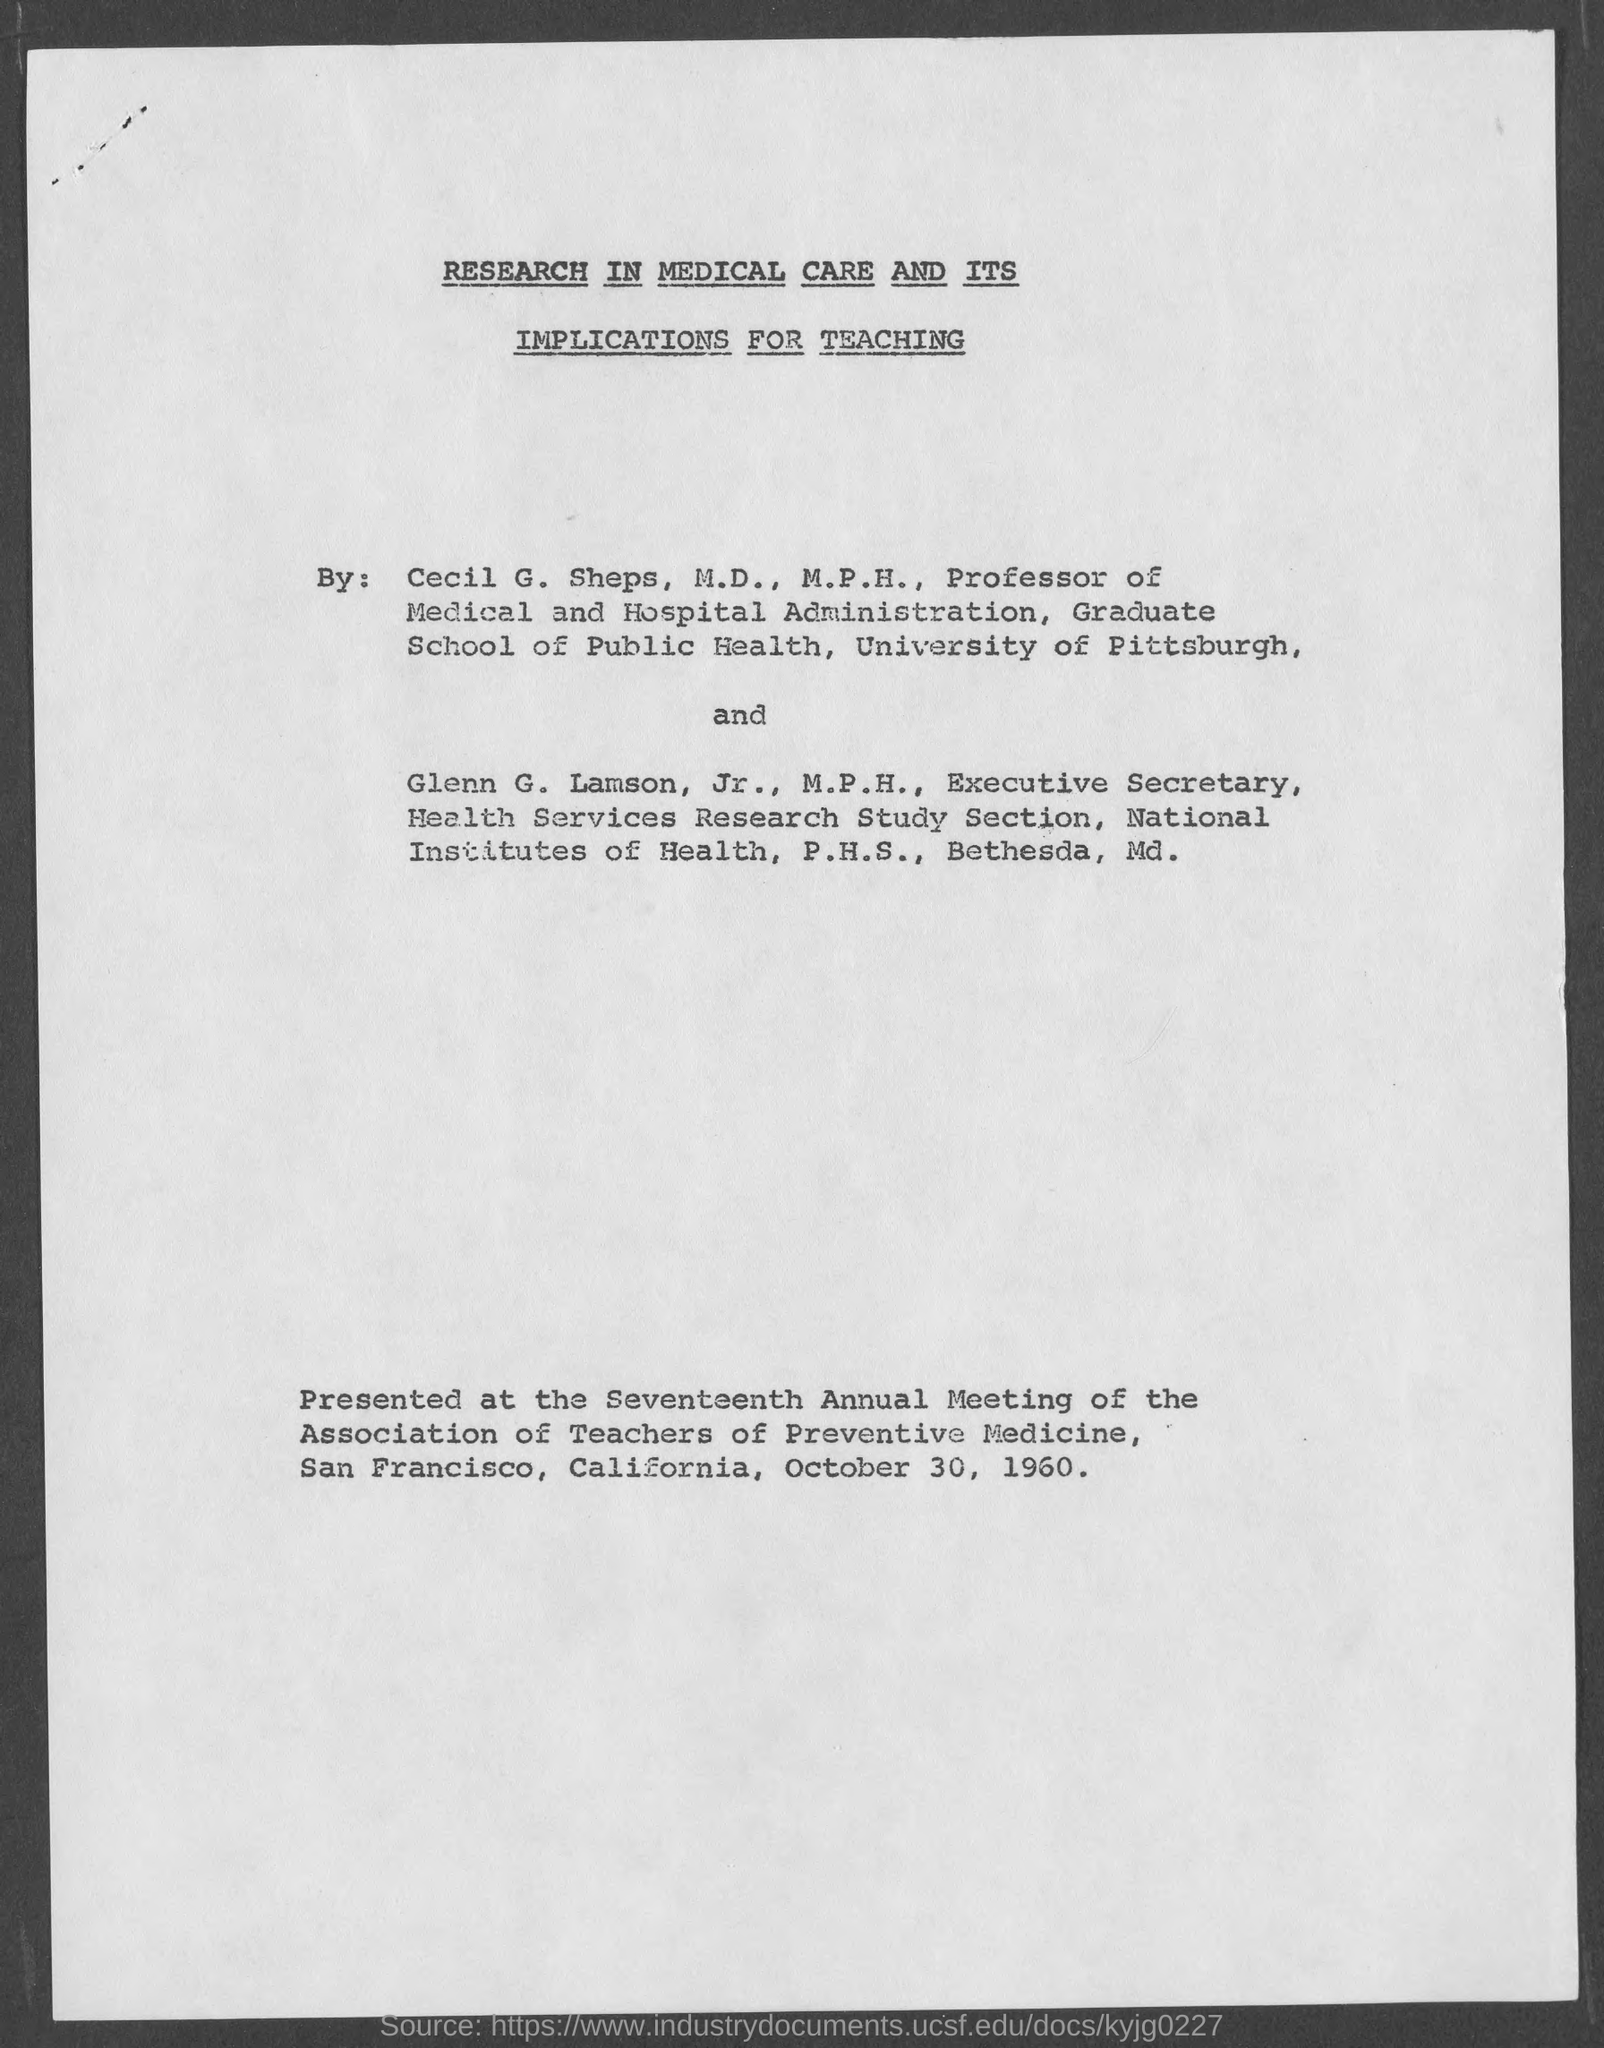Can you summarize the main themes of the paper discussed in the image? The paper 'Research in Medical Care and Its Implications for Teaching' primarily discusses the significant role of ongoing medical research in shaping the curriculum and teaching methods in preventive medicine. It stresses the need to integrate new research insights into educational frameworks to enhance the quality of medical education and practice. 